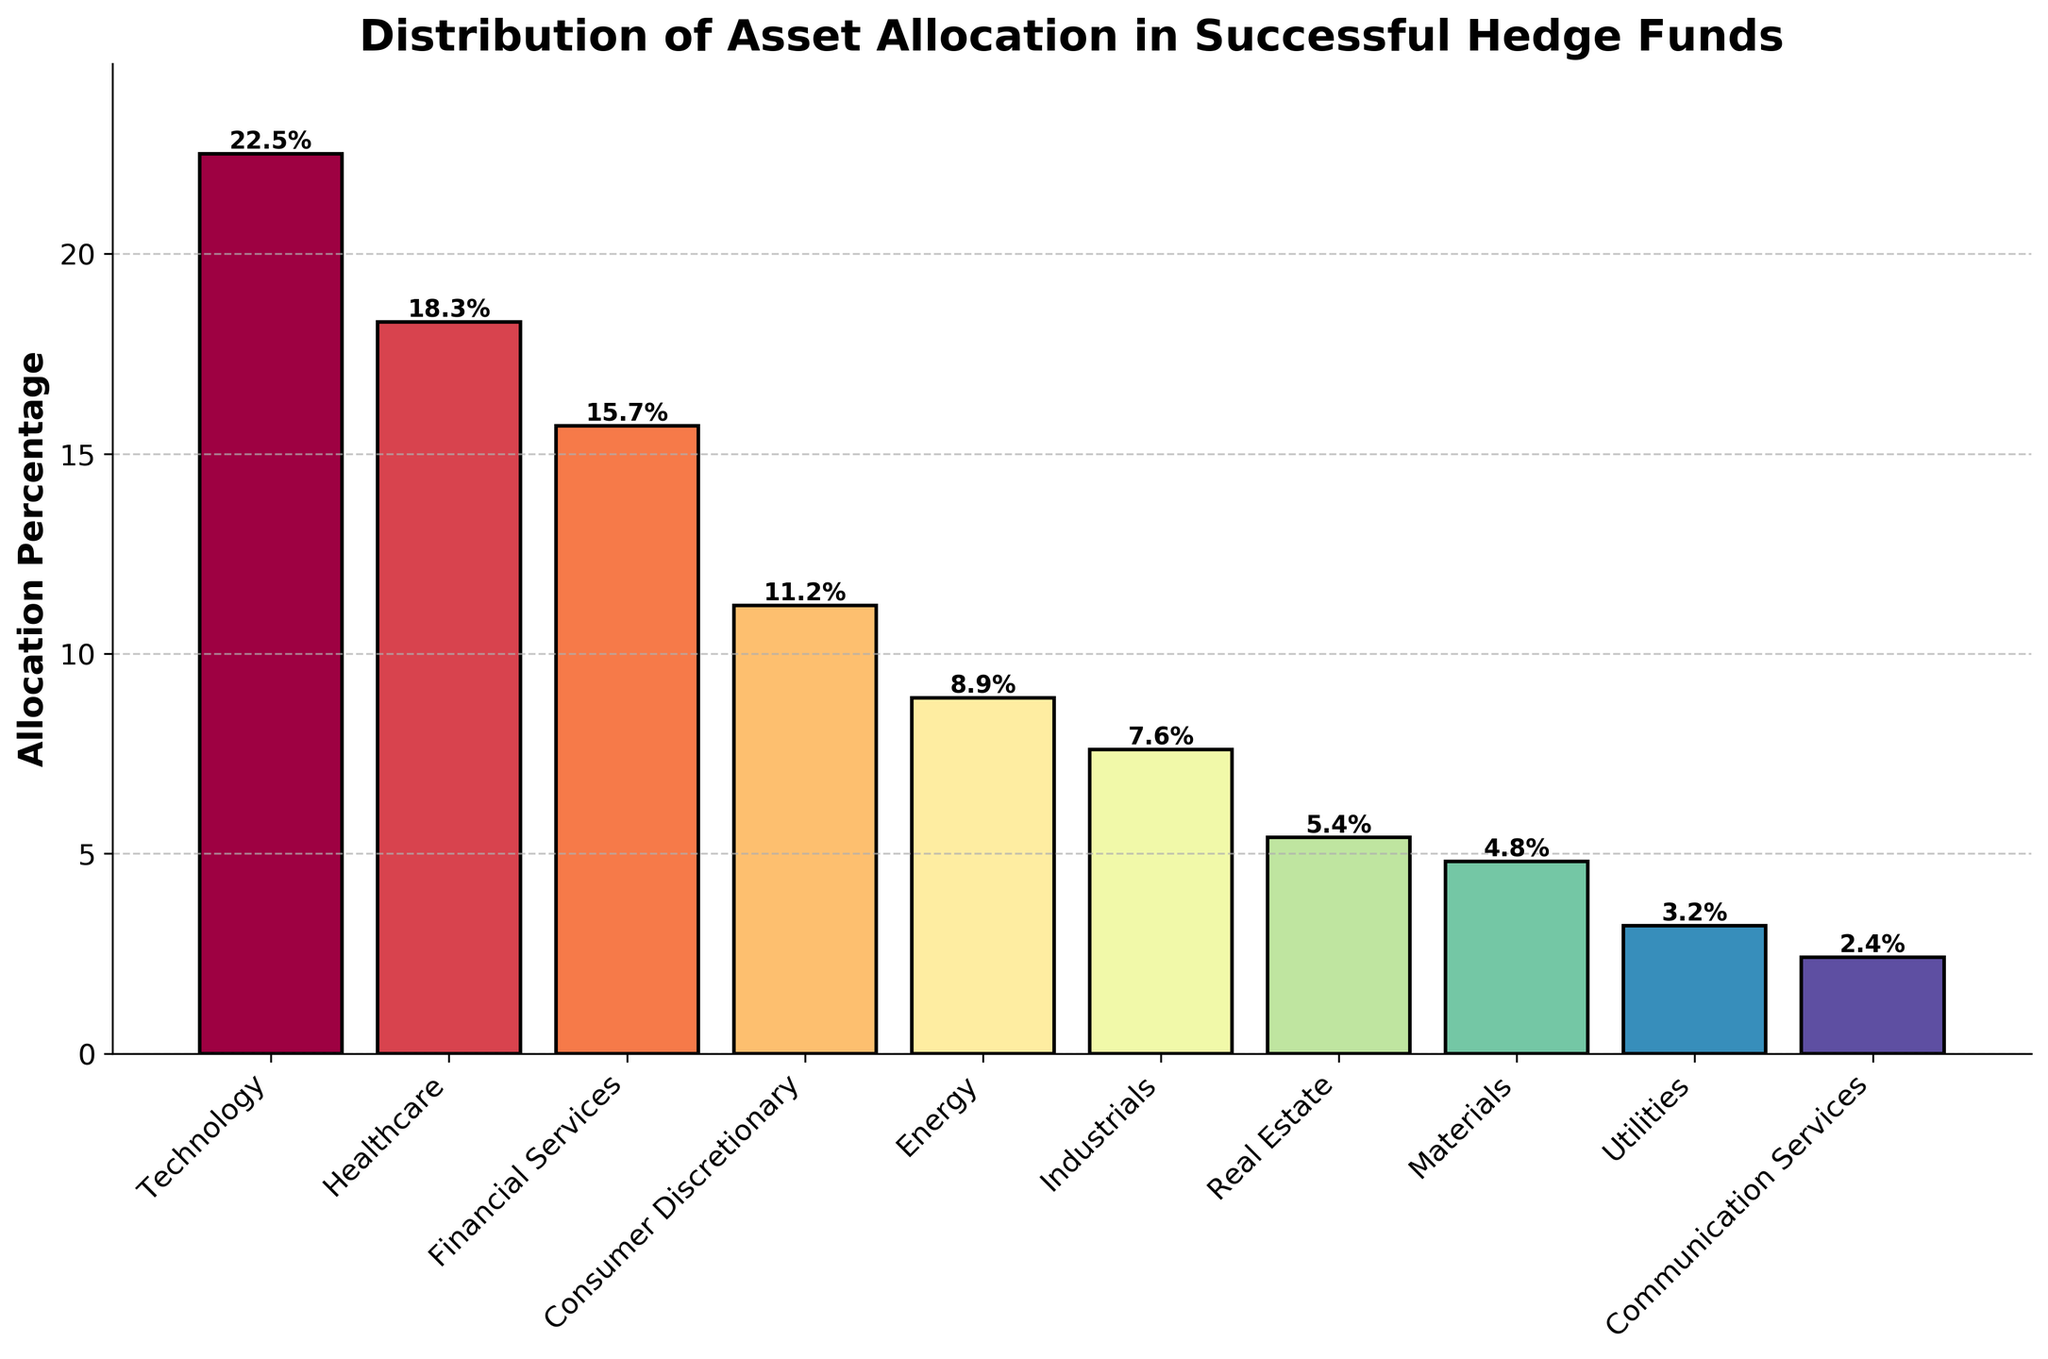What sector has the highest allocation percentage? The technology sector has the tallest bar in the chart, which represents the highest allocation percentage.
Answer: Technology What is the combined allocation percentage for Technology and Healthcare? Add the allocation percentages for Technology (22.5%) and Healthcare (18.3%). This results in 22.5 + 18.3 = 40.8%.
Answer: 40.8% Which sector has a higher allocation percentage, Industrials or Real Estate? Compare the bars for Industrials (7.6%) and Real Estate (5.4%). The bar for Industrials is taller.
Answer: Industrials What is the difference in allocation percentage between the sector with the highest and the sector with the lowest allocation? Subtract the allocation percentage of Communication Services (2.4%) from Technology (22.5%). This results in 22.5 - 2.4 = 20.1%.
Answer: 20.1% What sectors have an allocation percentage less than 5%? Identify the bars with a height less than 5%. The sectors are Materials (4.8%), Utilities (3.2%), and Communication Services (2.4%).
Answer: Materials, Utilities, Communication Services How many sectors have an allocation percentage greater than 10%? Count the bars with a height greater than 10%. These sectors are Technology (22.5%), Healthcare (18.3%), Financial Services (15.7%), and Consumer Discretionary (11.2%). There are 4 sectors in total.
Answer: 4 Which sectors have an allocation percentage within 2% of each other? Compare pairs of adjacent bars or bars that have close heights to identify those within 2% of each other. Financial Services (15.7%) and Consumer Discretionary (11.2%) are not within 2% of each other, but can compare similar heights. Missing an exact 2% pairs if not strict.
Answer: None What is the average allocation percentage for the top three sectors? Add the allocation percentages for the top three sectors (Technology: 22.5%, Healthcare: 18.3%, Financial Services: 15.7%) and divide by 3. This results in (22.5 + 18.3 + 15.7) / 3 = 56.5 / 3 = 18.83%.
Answer: 18.83% Is the allocation percentage of Consumer Discretionary greater than double that of Utilities? Compare the bar heights: Consumer Discretionary (11.2%) and double the allocation of Utilities (3.2 * 2 = 6.4%). 11.2% is greater.
Answer: Yes What sector has the smallest allocation percentage? The shortest bar in the chart represents the sector with the smallest allocation percentage, which is Communication Services (2.4%).
Answer: Communication Services 